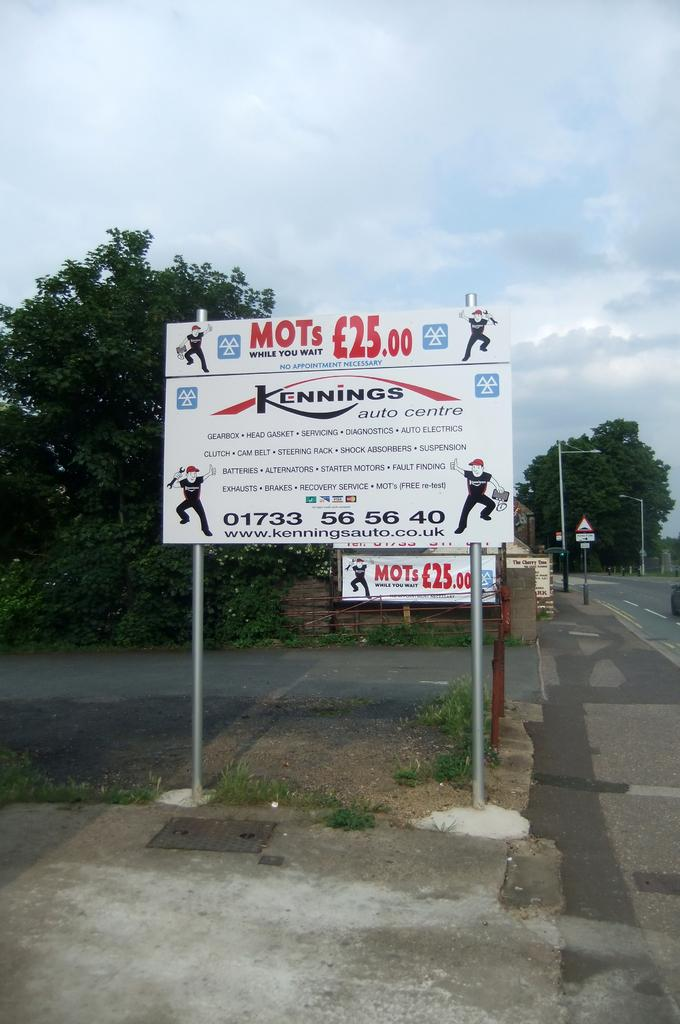<image>
Render a clear and concise summary of the photo. Kennings auto centre is being advertised on a sign on the side of the road. 